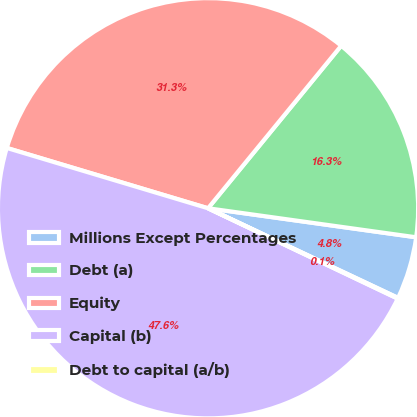Convert chart to OTSL. <chart><loc_0><loc_0><loc_500><loc_500><pie_chart><fcel>Millions Except Percentages<fcel>Debt (a)<fcel>Equity<fcel>Capital (b)<fcel>Debt to capital (a/b)<nl><fcel>4.81%<fcel>16.28%<fcel>31.29%<fcel>47.56%<fcel>0.06%<nl></chart> 